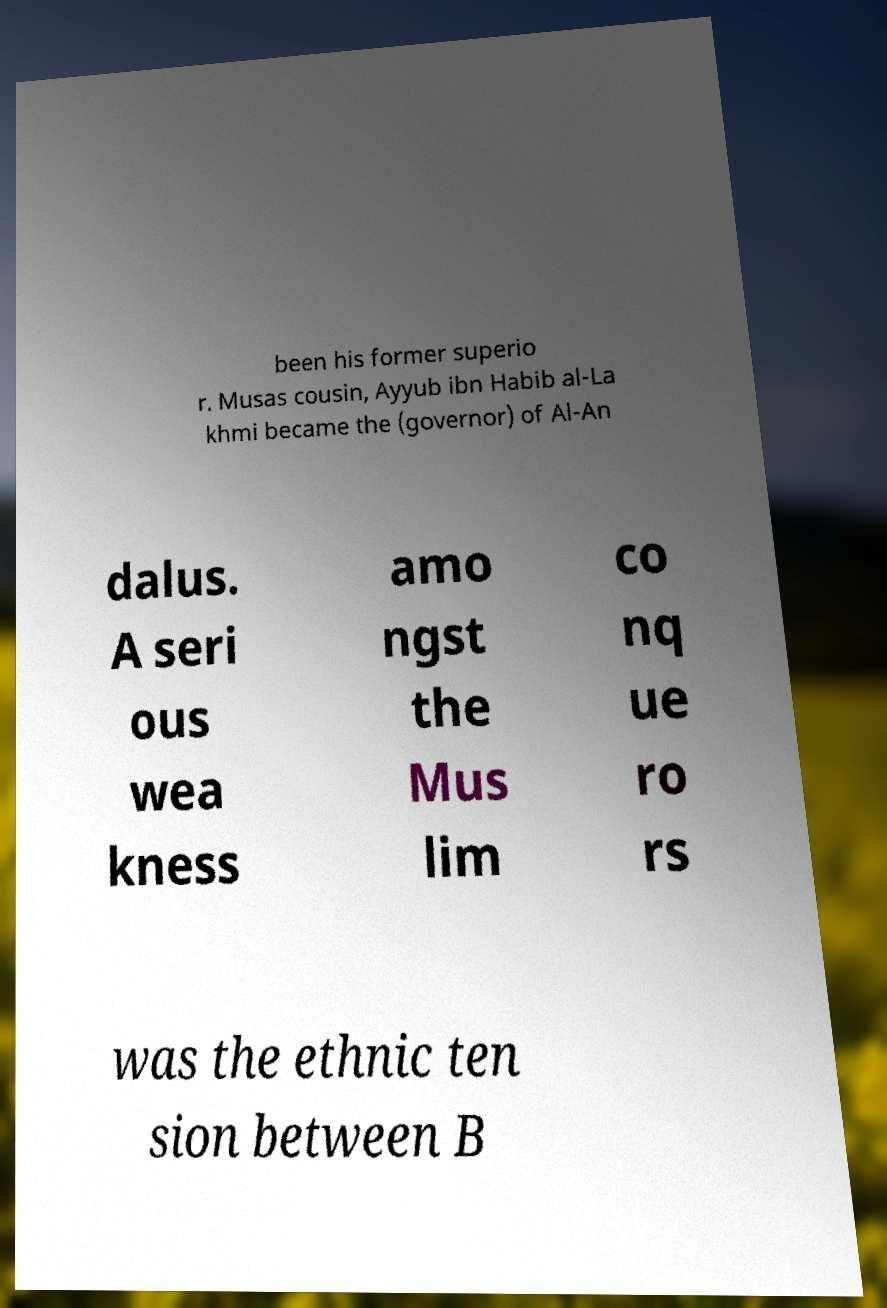Please read and relay the text visible in this image. What does it say? been his former superio r. Musas cousin, Ayyub ibn Habib al-La khmi became the (governor) of Al-An dalus. A seri ous wea kness amo ngst the Mus lim co nq ue ro rs was the ethnic ten sion between B 